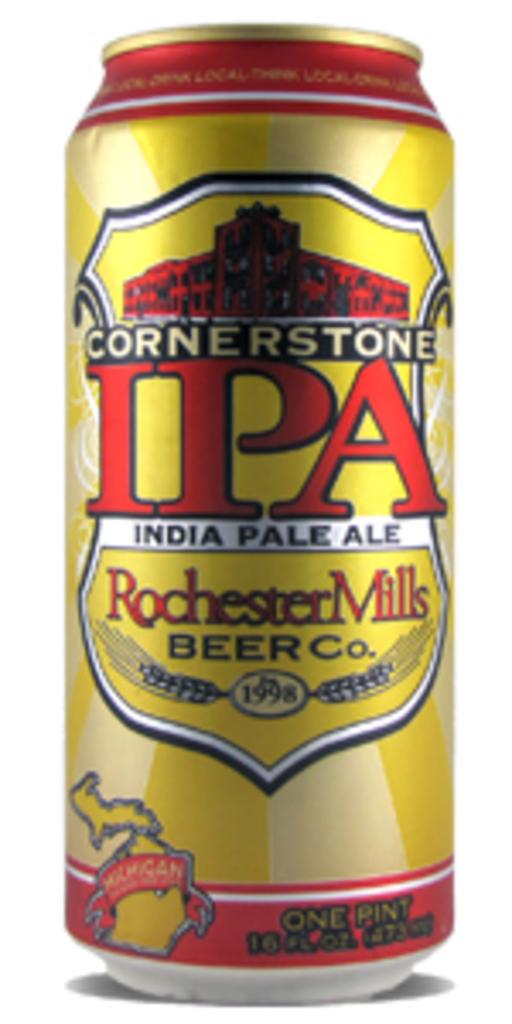Is this a can of beer?
Ensure brevity in your answer.  Yes. What year was rochester mills beer co. established?
Your response must be concise. 1998. 